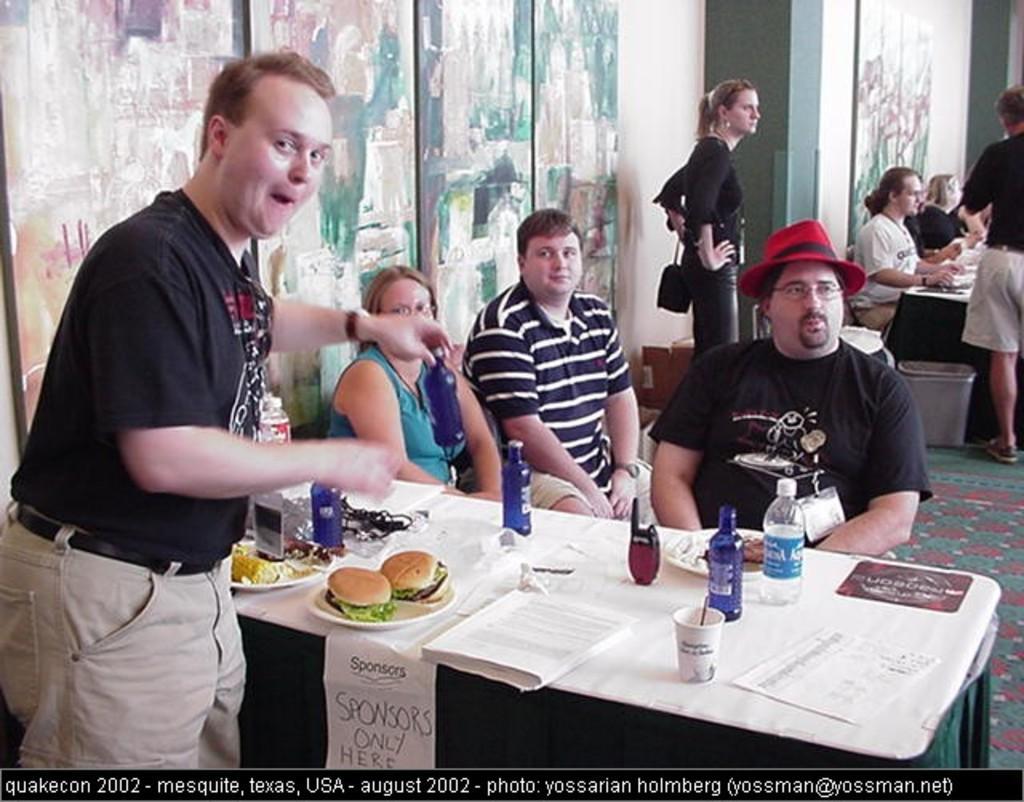Please provide a concise description of this image. This image consists of many persons. It looks like a restaurant. In the front, we can see a table on which there are burgers, bottles, paper and a book. In the background, there are wooden frames on the wall. At the bottom, there is a floor mat. 